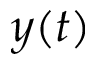Convert formula to latex. <formula><loc_0><loc_0><loc_500><loc_500>y ( t )</formula> 